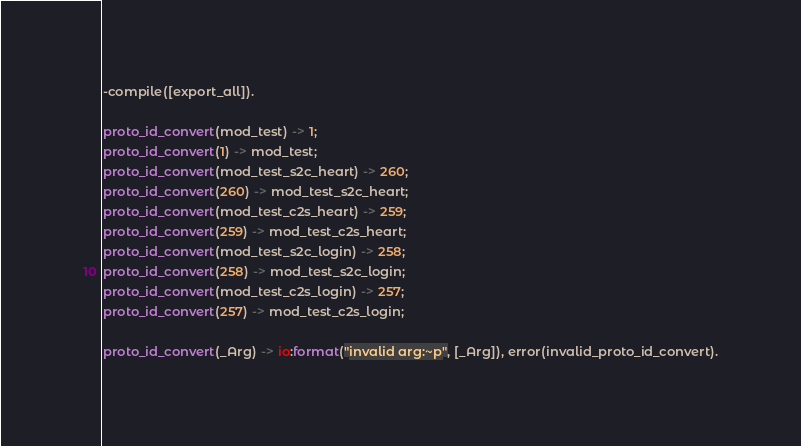Convert code to text. <code><loc_0><loc_0><loc_500><loc_500><_Erlang_>
-compile([export_all]).

proto_id_convert(mod_test) -> 1;
proto_id_convert(1) -> mod_test;
proto_id_convert(mod_test_s2c_heart) -> 260;
proto_id_convert(260) -> mod_test_s2c_heart;
proto_id_convert(mod_test_c2s_heart) -> 259;
proto_id_convert(259) -> mod_test_c2s_heart;
proto_id_convert(mod_test_s2c_login) -> 258;
proto_id_convert(258) -> mod_test_s2c_login;
proto_id_convert(mod_test_c2s_login) -> 257;
proto_id_convert(257) -> mod_test_c2s_login;

proto_id_convert(_Arg) -> io:format("invalid arg:~p", [_Arg]), error(invalid_proto_id_convert).</code> 